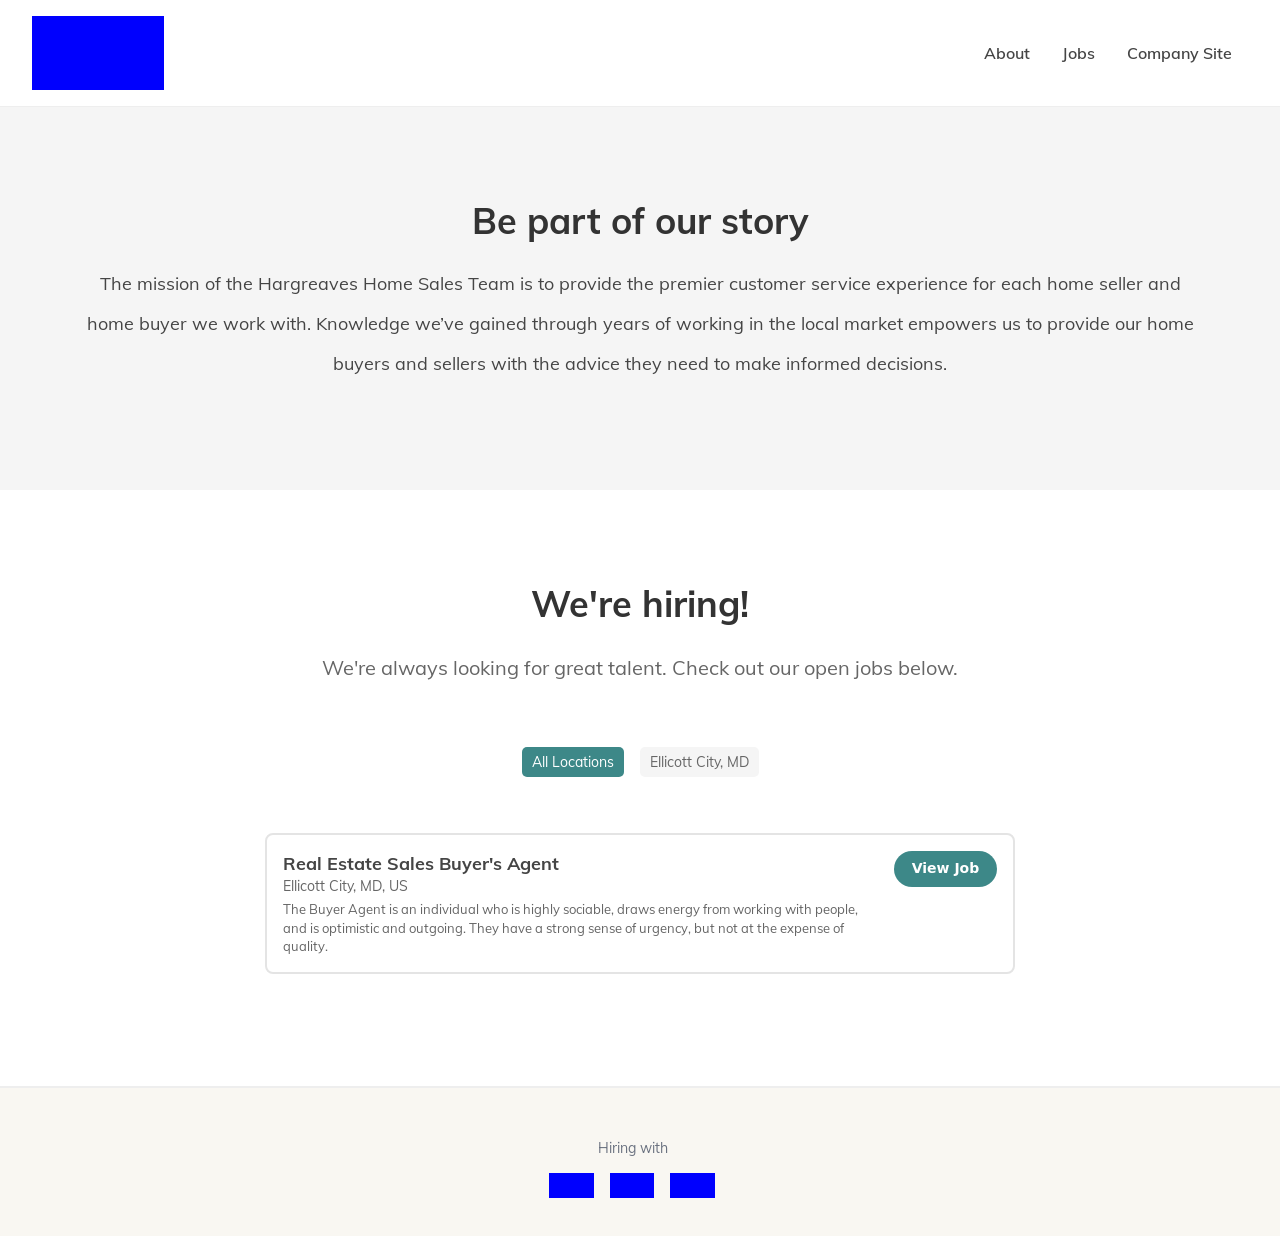Are there options for remote work or is the job location-bound? The job listing in the image does not specify remote work options. Typically, Real Estate Sales Buyer’s Agent positions require on-site visits and local travel, although some administrative tasks might be performed remotely depending on the company's policy. 